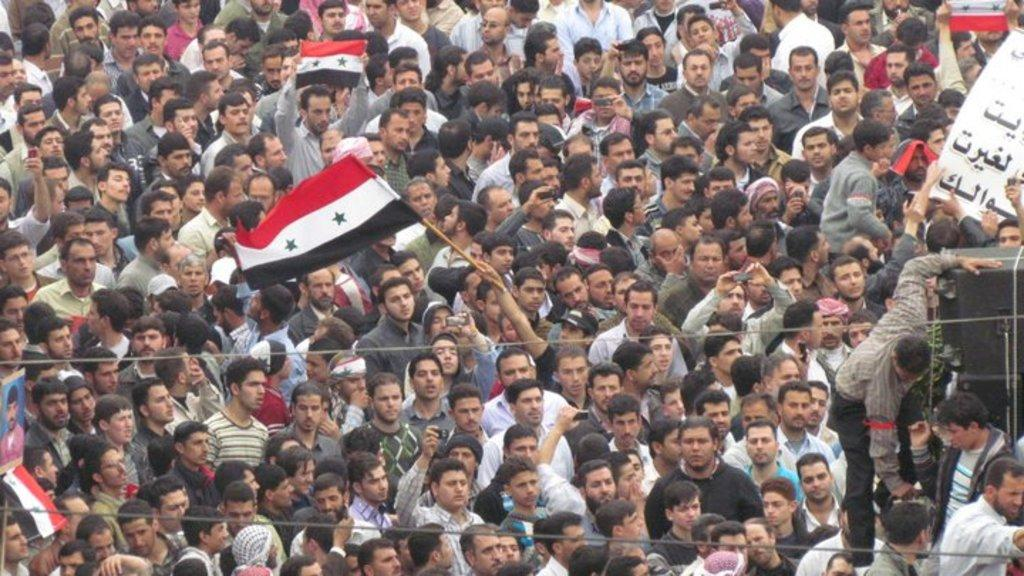What is the main subject of the image? The main subject of the image is a crowd. What are the people in the crowd holding? The people in the crowd are holding flags. What type of cherry is being used to decorate the beds in the image? There are no cherries or beds present in the image; it features a crowd of people holding flags. 